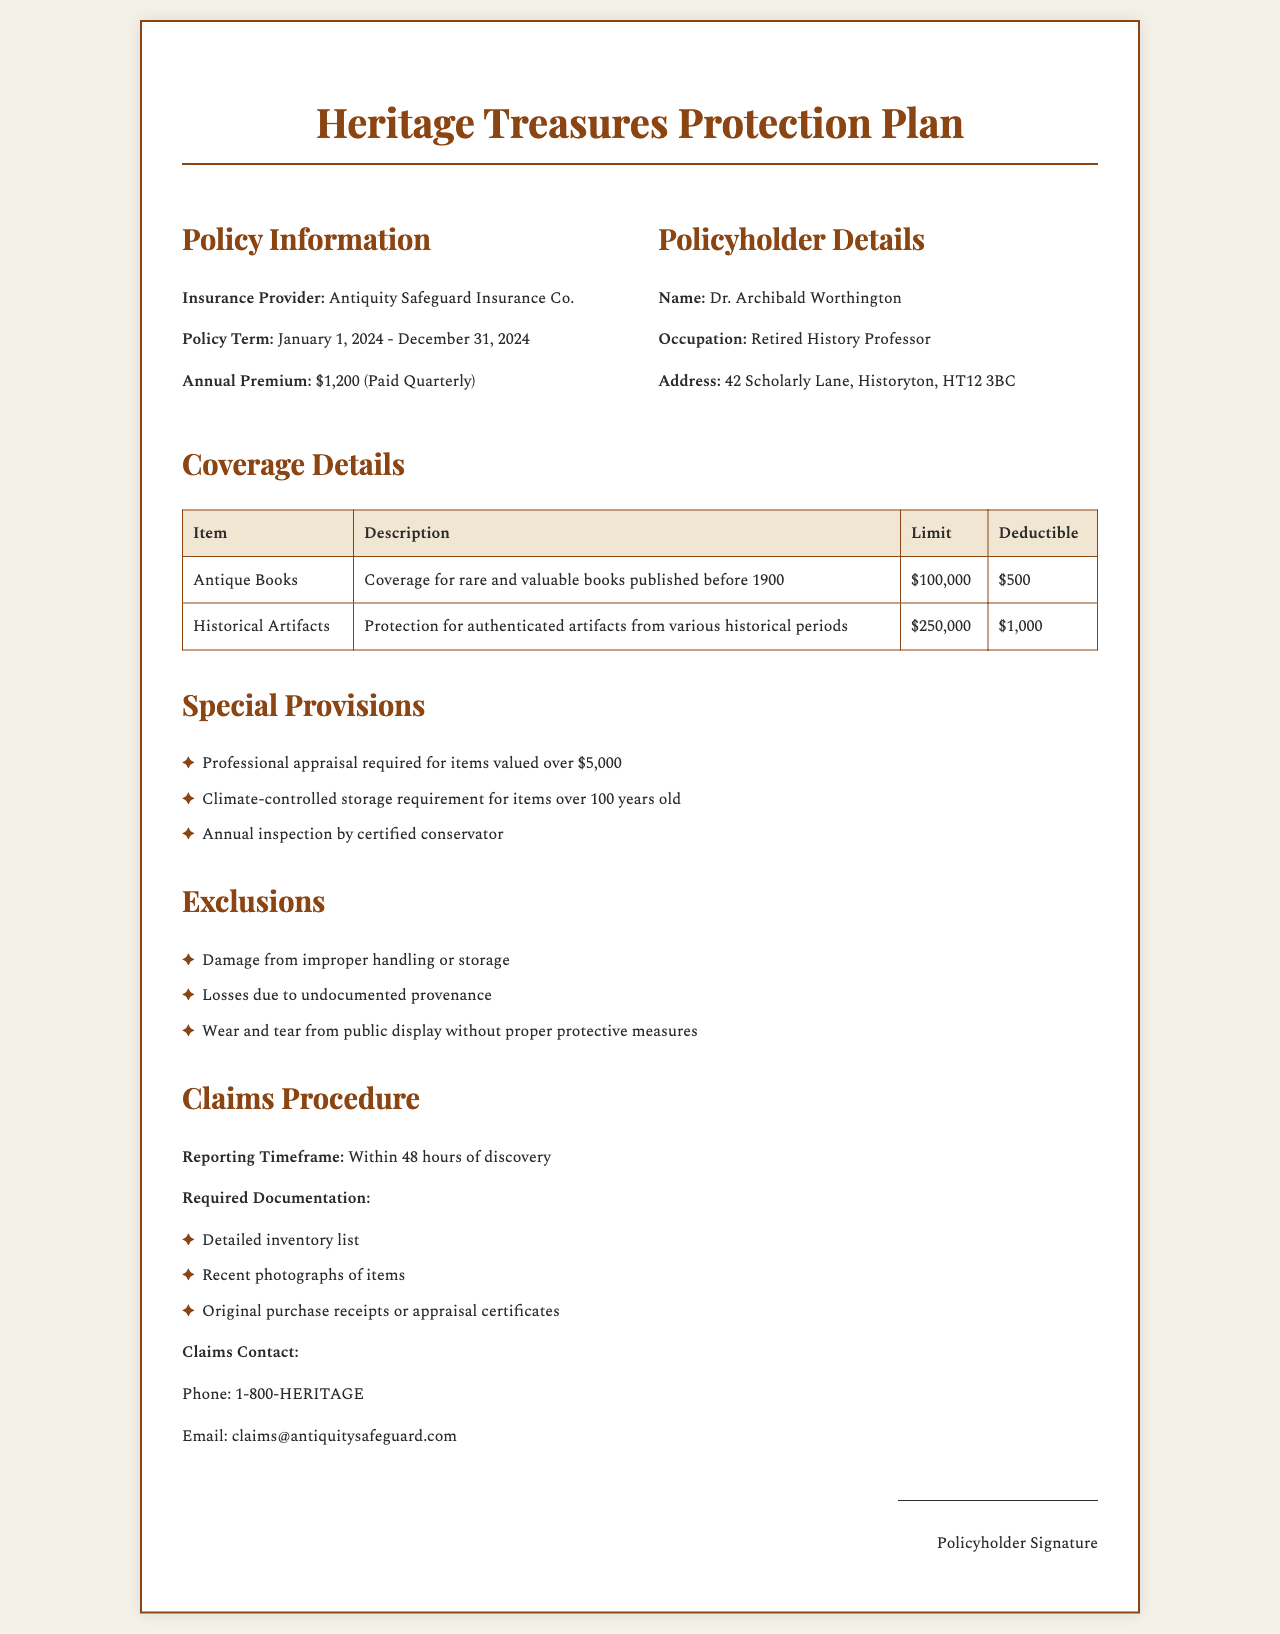What is the insurance provider? The insurance provider is mentioned directly in the policy information section.
Answer: Antiquity Safeguard Insurance Co What is the annual premium? The annual premium is specified under policy information details.
Answer: $1,200 What is the coverage limit for historical artifacts? The coverage limit is found in the coverage details table for historical artifacts.
Answer: $250,000 Who is the policyholder? The policyholder's name is given in the policyholder details section.
Answer: Dr. Archibald Worthington What is the required documentation for claims? The required documentation is listed under the claims procedure section.
Answer: Detailed inventory list What is the deductible for antique books? The deductible for antique books is presented in the coverage details table.
Answer: $500 What is the timeframe for reporting claims? The timeframe for reporting claims is specified in the claims procedure section.
Answer: Within 48 hours What is one exclusion in the policy? Exclusions are clearly listed in the exclusions section of the document.
Answer: Damage from improper handling or storage Who must conduct the annual inspection? The entity responsible for the annual inspection is mentioned in the special provisions.
Answer: Certified conservator 